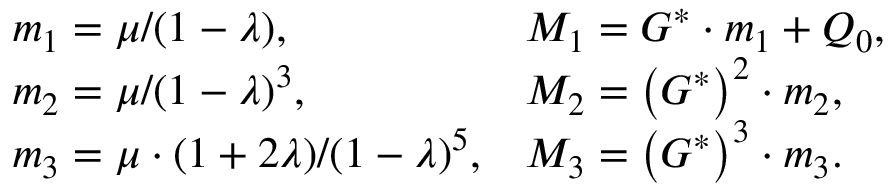Convert formula to latex. <formula><loc_0><loc_0><loc_500><loc_500>\begin{array} { l l } { m _ { 1 } = { \mu } / { ( 1 - \lambda ) } , } & { M _ { 1 } = G ^ { * } \cdot m _ { 1 } + Q _ { 0 } , } \\ { m _ { 2 } = { \mu } / { ( 1 - \lambda ) ^ { 3 } } , } & { M _ { 2 } = \left ( G ^ { * } \right ) ^ { 2 } \cdot m _ { 2 } , } \\ { m _ { 3 } = { \mu \cdot ( 1 + 2 \lambda ) } / { ( 1 - \lambda ) ^ { 5 } } , } & { M _ { 3 } = \left ( G ^ { * } \right ) ^ { 3 } \cdot m _ { 3 } . } \end{array}</formula> 